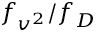Convert formula to latex. <formula><loc_0><loc_0><loc_500><loc_500>f _ { v ^ { 2 } } / f _ { D }</formula> 